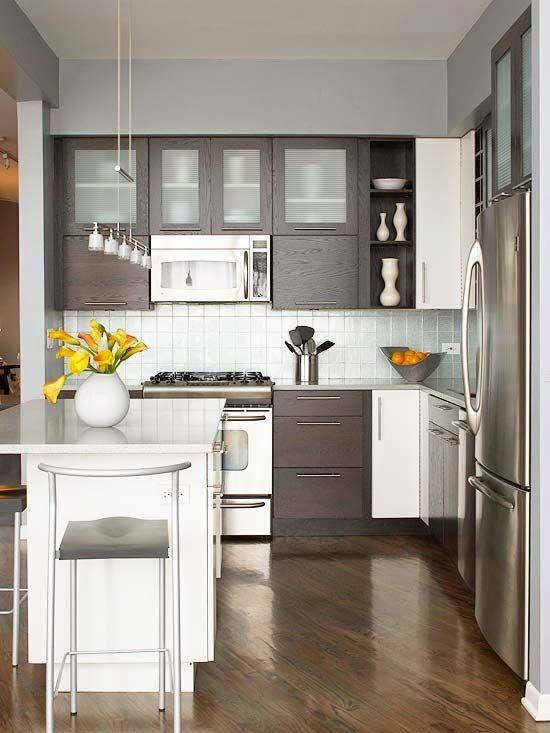Considering the design and items within this kitchen, what can be inferred about the resident's preference for kitchen functionality and aesthetic? Based on the image, the resident appears to prefer a clean, modern aesthetic with a neutral color palette, accented by natural elements like the wooden floor and fresh flowers. The presence of a coffee maker suggests a routine that includes coffee, implying a functional use of space for daily rituals. The selection of stainless steel appliances indicates a preference for durable, easy-to-clean surfaces that also provide a sleek look. The addition of a small island with a single stool suggests that the resident might appreciate a quick and casual dining area, possibly for solo use or a small number of people, prioritizing space efficiency over larger dining arrangements. Overall, the kitchen seems designed for both practical use and visual appeal, with careful attention to color coordination and material quality. 